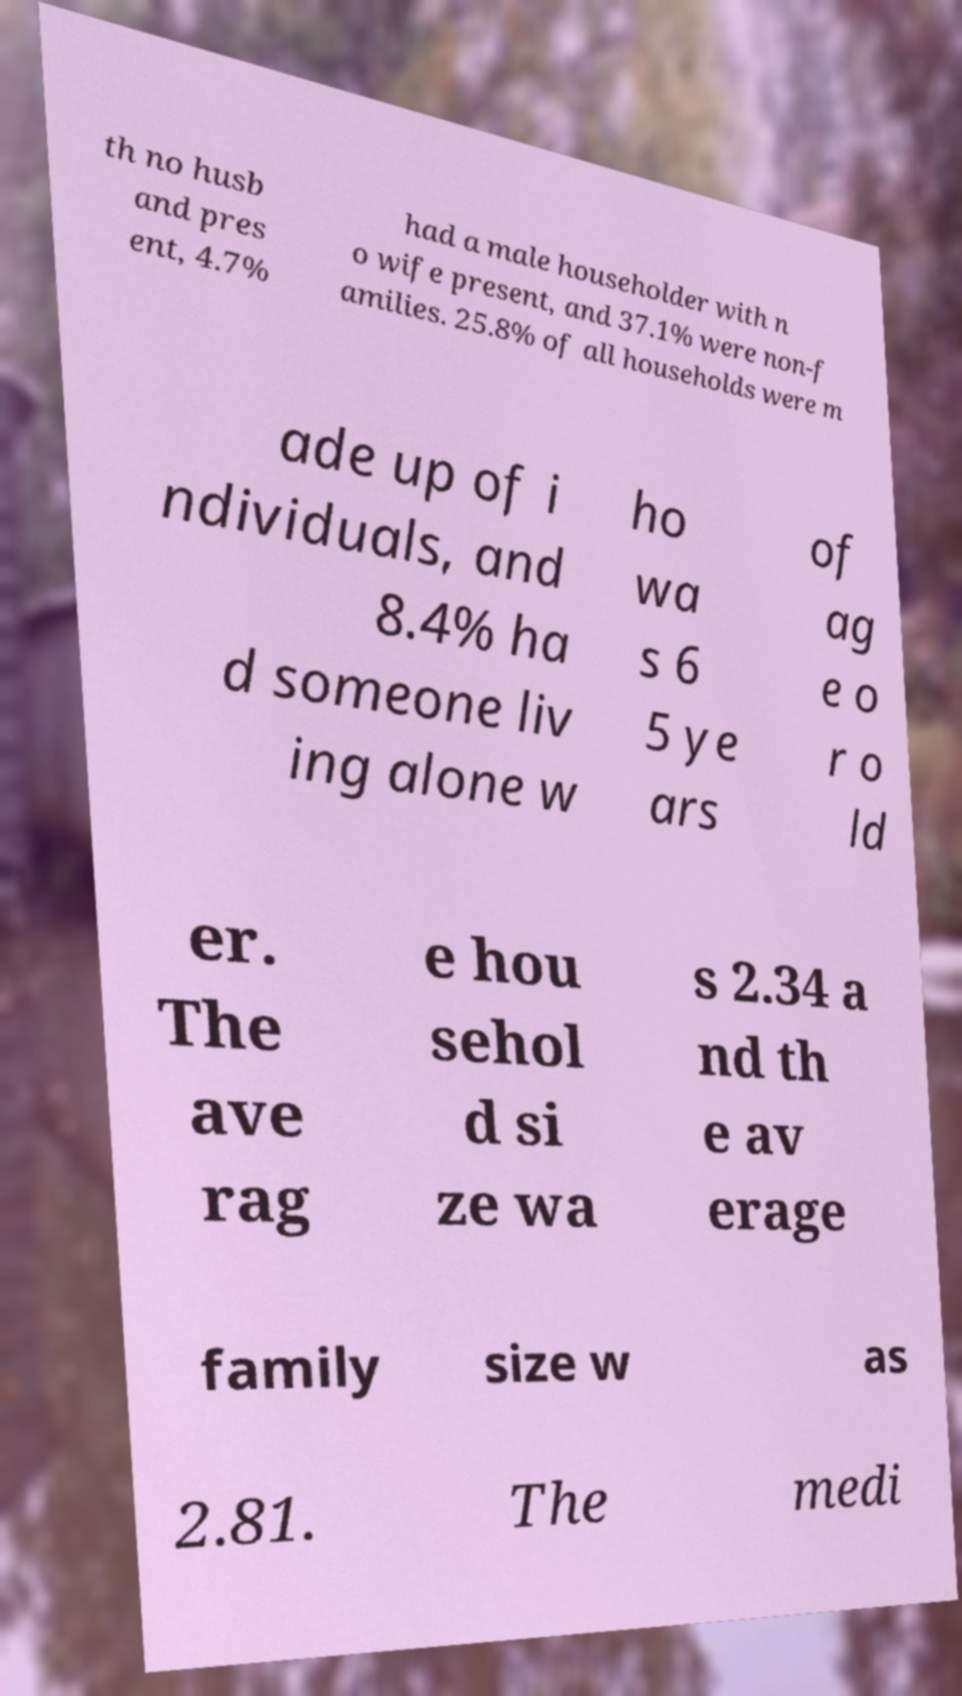Please identify and transcribe the text found in this image. th no husb and pres ent, 4.7% had a male householder with n o wife present, and 37.1% were non-f amilies. 25.8% of all households were m ade up of i ndividuals, and 8.4% ha d someone liv ing alone w ho wa s 6 5 ye ars of ag e o r o ld er. The ave rag e hou sehol d si ze wa s 2.34 a nd th e av erage family size w as 2.81. The medi 